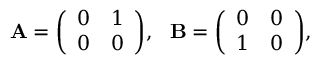<formula> <loc_0><loc_0><loc_500><loc_500>A = { \left ( \begin{array} { l l } { 0 } & { 1 } \\ { 0 } & { 0 } \end{array} \right ) } , \ \ B = { \left ( \begin{array} { l l } { 0 } & { 0 } \\ { 1 } & { 0 } \end{array} \right ) } ,</formula> 